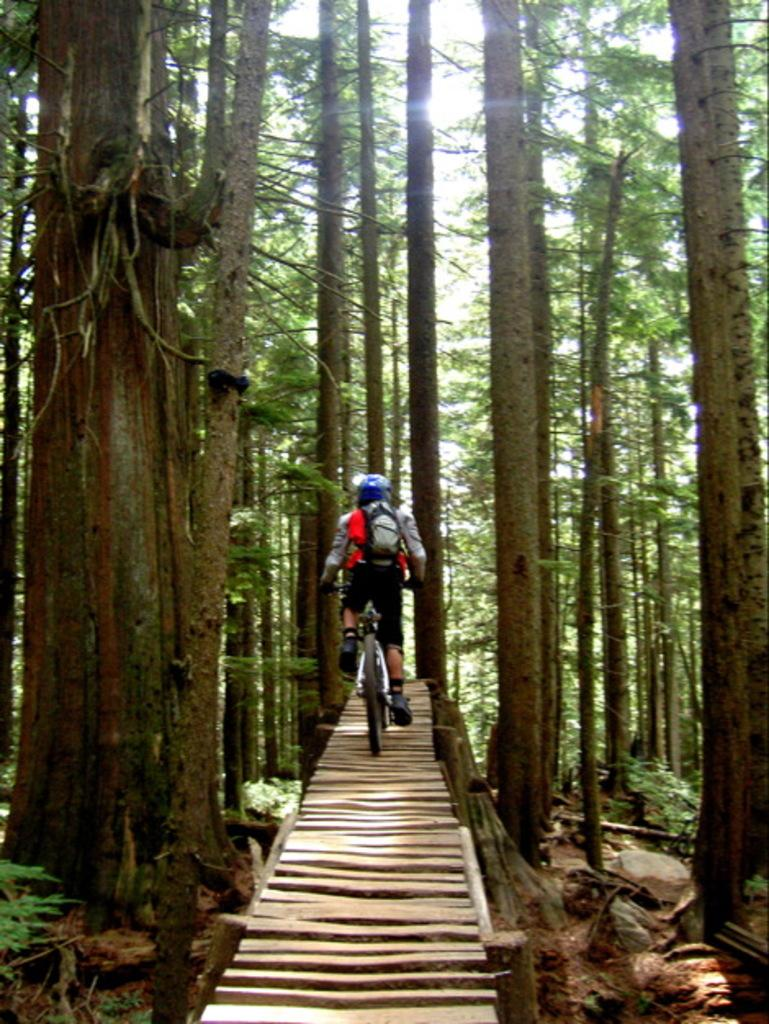What is the main subject of the image? There is a person in the image. What is the person doing in the image? The person is riding a bike. What can be seen beside the person in the image? There is a group of trees beside the person. What is visible at the top of the image? The sky is visible at the top of the image. What type of mouth can be seen on the edge of the memory in the image? There is no mouth, edge, or memory present in the image. 